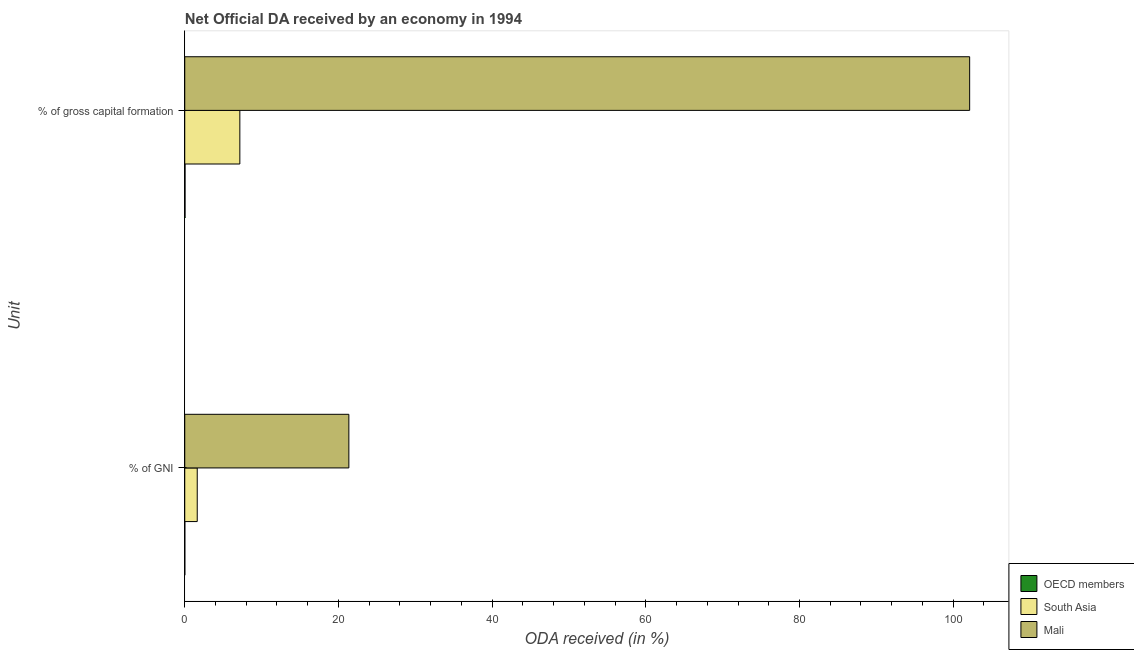Are the number of bars per tick equal to the number of legend labels?
Make the answer very short. Yes. Are the number of bars on each tick of the Y-axis equal?
Offer a very short reply. Yes. How many bars are there on the 2nd tick from the bottom?
Provide a short and direct response. 3. What is the label of the 1st group of bars from the top?
Offer a terse response. % of gross capital formation. What is the oda received as percentage of gni in South Asia?
Your answer should be compact. 1.62. Across all countries, what is the maximum oda received as percentage of gross capital formation?
Offer a very short reply. 102.15. Across all countries, what is the minimum oda received as percentage of gross capital formation?
Ensure brevity in your answer.  0.04. In which country was the oda received as percentage of gni maximum?
Give a very brief answer. Mali. In which country was the oda received as percentage of gross capital formation minimum?
Provide a succinct answer. OECD members. What is the total oda received as percentage of gni in the graph?
Give a very brief answer. 22.99. What is the difference between the oda received as percentage of gross capital formation in OECD members and that in Mali?
Offer a terse response. -102.11. What is the difference between the oda received as percentage of gni in Mali and the oda received as percentage of gross capital formation in South Asia?
Keep it short and to the point. 14.19. What is the average oda received as percentage of gni per country?
Provide a short and direct response. 7.66. What is the difference between the oda received as percentage of gni and oda received as percentage of gross capital formation in Mali?
Keep it short and to the point. -80.79. What is the ratio of the oda received as percentage of gross capital formation in Mali to that in South Asia?
Make the answer very short. 14.25. Is the oda received as percentage of gross capital formation in OECD members less than that in South Asia?
Give a very brief answer. Yes. What does the 3rd bar from the top in % of GNI represents?
Give a very brief answer. OECD members. What does the 1st bar from the bottom in % of gross capital formation represents?
Offer a very short reply. OECD members. Are all the bars in the graph horizontal?
Give a very brief answer. Yes. What is the difference between two consecutive major ticks on the X-axis?
Offer a terse response. 20. Does the graph contain any zero values?
Provide a succinct answer. No. Does the graph contain grids?
Make the answer very short. No. Where does the legend appear in the graph?
Ensure brevity in your answer.  Bottom right. What is the title of the graph?
Provide a short and direct response. Net Official DA received by an economy in 1994. Does "Greenland" appear as one of the legend labels in the graph?
Provide a succinct answer. No. What is the label or title of the X-axis?
Give a very brief answer. ODA received (in %). What is the label or title of the Y-axis?
Provide a succinct answer. Unit. What is the ODA received (in %) of OECD members in % of GNI?
Offer a terse response. 0.01. What is the ODA received (in %) in South Asia in % of GNI?
Offer a very short reply. 1.62. What is the ODA received (in %) of Mali in % of GNI?
Your answer should be very brief. 21.36. What is the ODA received (in %) in OECD members in % of gross capital formation?
Keep it short and to the point. 0.04. What is the ODA received (in %) in South Asia in % of gross capital formation?
Provide a succinct answer. 7.17. What is the ODA received (in %) in Mali in % of gross capital formation?
Give a very brief answer. 102.15. Across all Unit, what is the maximum ODA received (in %) in OECD members?
Your answer should be compact. 0.04. Across all Unit, what is the maximum ODA received (in %) in South Asia?
Keep it short and to the point. 7.17. Across all Unit, what is the maximum ODA received (in %) of Mali?
Offer a very short reply. 102.15. Across all Unit, what is the minimum ODA received (in %) in OECD members?
Offer a terse response. 0.01. Across all Unit, what is the minimum ODA received (in %) of South Asia?
Provide a short and direct response. 1.62. Across all Unit, what is the minimum ODA received (in %) of Mali?
Offer a terse response. 21.36. What is the total ODA received (in %) of OECD members in the graph?
Your response must be concise. 0.04. What is the total ODA received (in %) of South Asia in the graph?
Keep it short and to the point. 8.79. What is the total ODA received (in %) in Mali in the graph?
Provide a short and direct response. 123.5. What is the difference between the ODA received (in %) in OECD members in % of GNI and that in % of gross capital formation?
Your answer should be very brief. -0.03. What is the difference between the ODA received (in %) in South Asia in % of GNI and that in % of gross capital formation?
Your response must be concise. -5.55. What is the difference between the ODA received (in %) of Mali in % of GNI and that in % of gross capital formation?
Give a very brief answer. -80.79. What is the difference between the ODA received (in %) in OECD members in % of GNI and the ODA received (in %) in South Asia in % of gross capital formation?
Offer a very short reply. -7.16. What is the difference between the ODA received (in %) in OECD members in % of GNI and the ODA received (in %) in Mali in % of gross capital formation?
Your answer should be very brief. -102.14. What is the difference between the ODA received (in %) of South Asia in % of GNI and the ODA received (in %) of Mali in % of gross capital formation?
Ensure brevity in your answer.  -100.52. What is the average ODA received (in %) in OECD members per Unit?
Provide a short and direct response. 0.02. What is the average ODA received (in %) of South Asia per Unit?
Your response must be concise. 4.4. What is the average ODA received (in %) of Mali per Unit?
Make the answer very short. 61.75. What is the difference between the ODA received (in %) in OECD members and ODA received (in %) in South Asia in % of GNI?
Give a very brief answer. -1.62. What is the difference between the ODA received (in %) in OECD members and ODA received (in %) in Mali in % of GNI?
Your answer should be very brief. -21.35. What is the difference between the ODA received (in %) of South Asia and ODA received (in %) of Mali in % of GNI?
Provide a short and direct response. -19.73. What is the difference between the ODA received (in %) of OECD members and ODA received (in %) of South Asia in % of gross capital formation?
Your response must be concise. -7.13. What is the difference between the ODA received (in %) of OECD members and ODA received (in %) of Mali in % of gross capital formation?
Your answer should be compact. -102.11. What is the difference between the ODA received (in %) of South Asia and ODA received (in %) of Mali in % of gross capital formation?
Offer a very short reply. -94.98. What is the ratio of the ODA received (in %) of OECD members in % of GNI to that in % of gross capital formation?
Your answer should be compact. 0.23. What is the ratio of the ODA received (in %) of South Asia in % of GNI to that in % of gross capital formation?
Provide a succinct answer. 0.23. What is the ratio of the ODA received (in %) of Mali in % of GNI to that in % of gross capital formation?
Offer a terse response. 0.21. What is the difference between the highest and the second highest ODA received (in %) in OECD members?
Provide a succinct answer. 0.03. What is the difference between the highest and the second highest ODA received (in %) of South Asia?
Make the answer very short. 5.55. What is the difference between the highest and the second highest ODA received (in %) in Mali?
Offer a very short reply. 80.79. What is the difference between the highest and the lowest ODA received (in %) of OECD members?
Offer a terse response. 0.03. What is the difference between the highest and the lowest ODA received (in %) of South Asia?
Your response must be concise. 5.55. What is the difference between the highest and the lowest ODA received (in %) in Mali?
Make the answer very short. 80.79. 